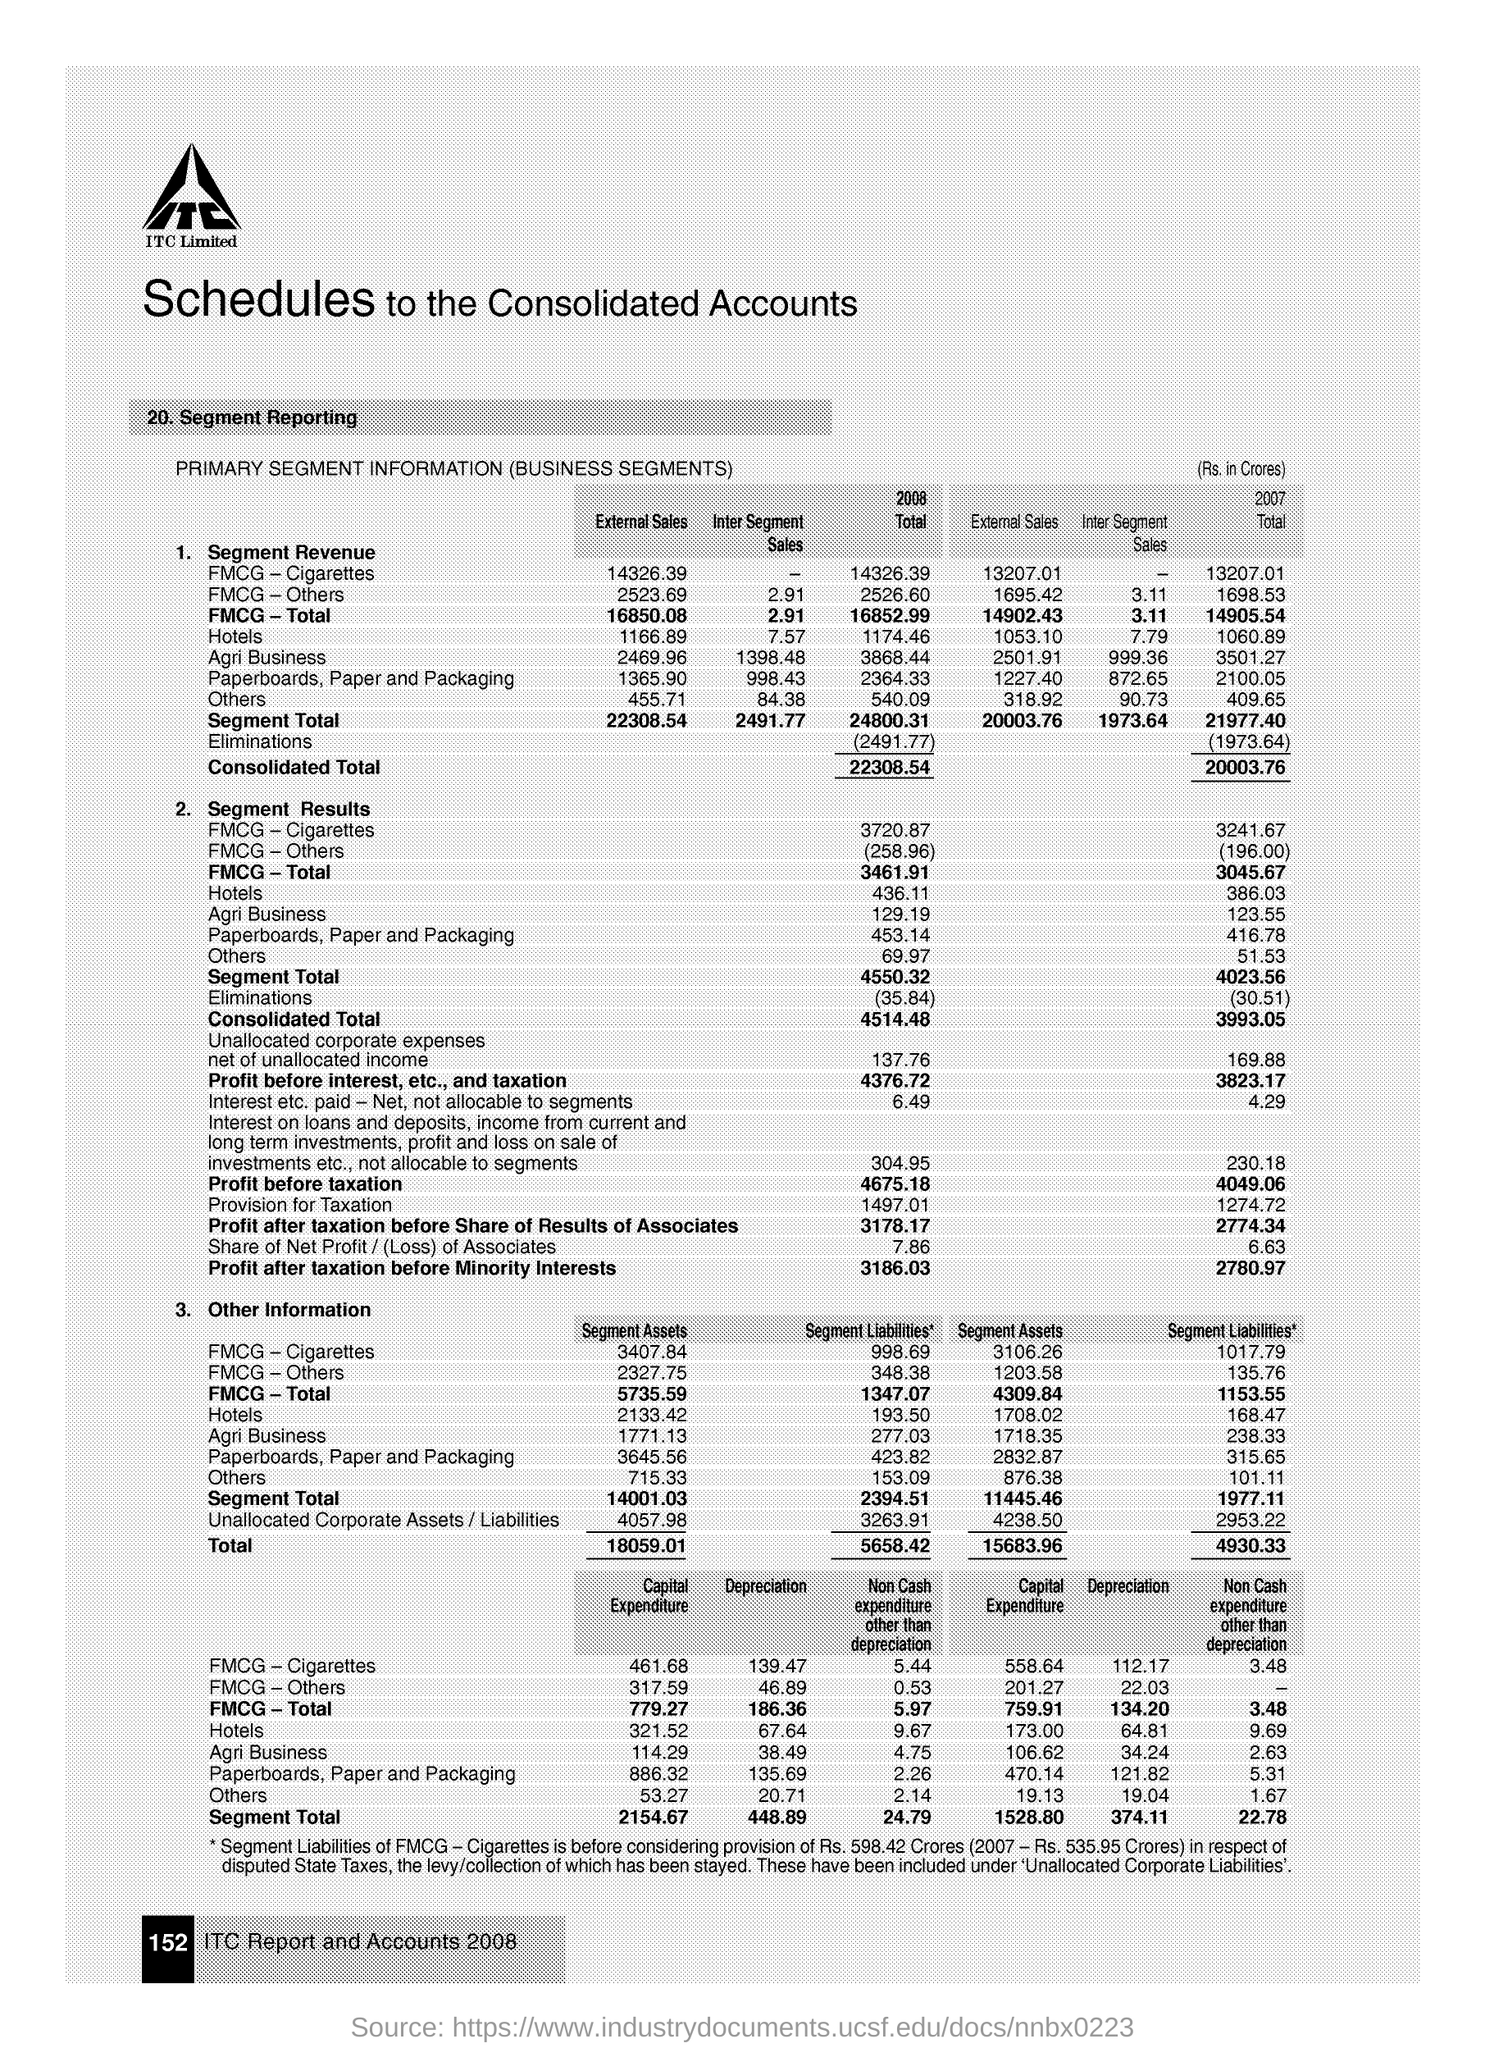Point out several critical features in this image. The profit before taxation for 2007 was 4049.06. The profit before taxation for 2008 was 4,675.18. The profit after taxation before minority interests for 2007 was 2,780.97. The profit after taxation before share of results of associates for 2007 was 2774.34. The profit after taxation, before accounting for the results of associates, for the year 2008 was 3,178.17. 